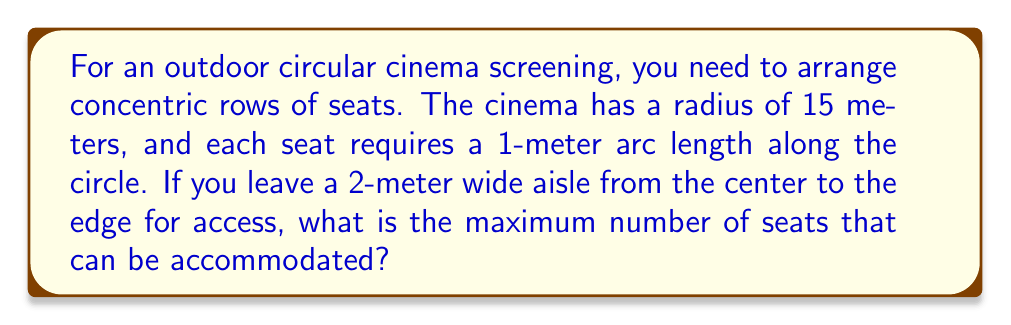Teach me how to tackle this problem. Let's approach this step-by-step:

1) First, we need to calculate the area that can be used for seating. The total area of the cinema is $\pi r^2 = \pi (15^2) = 225\pi$ square meters.

2) The aisle takes up a rectangular area of $2 * 15 = 30$ square meters.

3) The area available for seating is thus $225\pi - 30$ square meters.

4) Now, we need to determine how many concentric circles of seats we can fit. The radii of these circles will be 3, 4, 5, ..., 15 meters (starting at 3 due to the 2-meter aisle).

5) For each circle, we can calculate the number of seats by dividing the circumference by 1 (the arc length each seat requires):

   $\text{Seats in circle} = \frac{2\pi r}{1} = 2\pi r$

6) Let's sum this up for r = 3 to 15:

   $\sum_{r=3}^{15} 2\pi r = 2\pi (3 + 4 + 5 + ... + 15)$

7) The sum of integers from 3 to 15 is:

   $\frac{(15+3)(15-3+1)}{2} = \frac{18 * 13}{2} = 117$

8) Therefore, the total number of seats is:

   $2\pi * 117 = 234\pi$

9) Since we can only have whole seats, we round down to the nearest integer.
Answer: $\lfloor 234\pi \rfloor = 735$ seats 